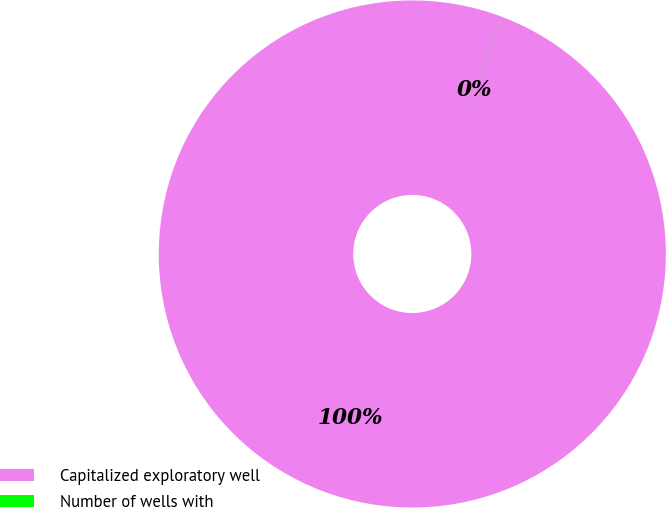Convert chart. <chart><loc_0><loc_0><loc_500><loc_500><pie_chart><fcel>Capitalized exploratory well<fcel>Number of wells with<nl><fcel>99.99%<fcel>0.01%<nl></chart> 